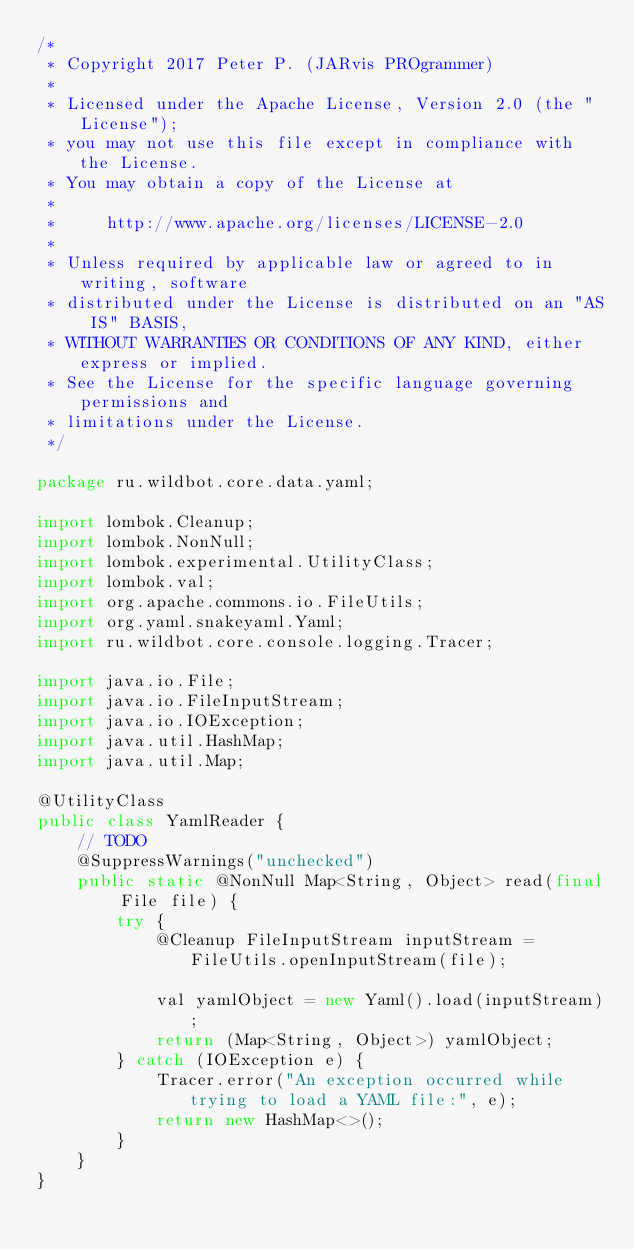<code> <loc_0><loc_0><loc_500><loc_500><_Java_>/*
 * Copyright 2017 Peter P. (JARvis PROgrammer)
 *
 * Licensed under the Apache License, Version 2.0 (the "License");
 * you may not use this file except in compliance with the License.
 * You may obtain a copy of the License at
 *
 *     http://www.apache.org/licenses/LICENSE-2.0
 *
 * Unless required by applicable law or agreed to in writing, software
 * distributed under the License is distributed on an "AS IS" BASIS,
 * WITHOUT WARRANTIES OR CONDITIONS OF ANY KIND, either express or implied.
 * See the License for the specific language governing permissions and
 * limitations under the License.
 */

package ru.wildbot.core.data.yaml;

import lombok.Cleanup;
import lombok.NonNull;
import lombok.experimental.UtilityClass;
import lombok.val;
import org.apache.commons.io.FileUtils;
import org.yaml.snakeyaml.Yaml;
import ru.wildbot.core.console.logging.Tracer;

import java.io.File;
import java.io.FileInputStream;
import java.io.IOException;
import java.util.HashMap;
import java.util.Map;

@UtilityClass
public class YamlReader {
    // TODO
    @SuppressWarnings("unchecked")
    public static @NonNull Map<String, Object> read(final File file) {
        try {
            @Cleanup FileInputStream inputStream = FileUtils.openInputStream(file);

            val yamlObject = new Yaml().load(inputStream);
            return (Map<String, Object>) yamlObject;
        } catch (IOException e) {
            Tracer.error("An exception occurred while trying to load a YAML file:", e);
            return new HashMap<>();
        }
    }
}
</code> 